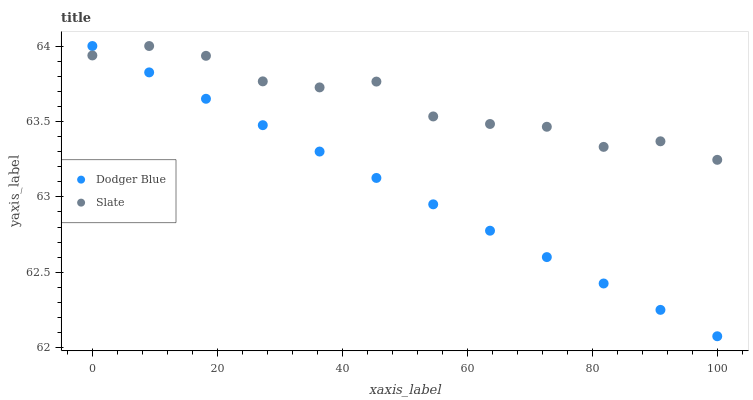Does Dodger Blue have the minimum area under the curve?
Answer yes or no. Yes. Does Slate have the maximum area under the curve?
Answer yes or no. Yes. Does Dodger Blue have the maximum area under the curve?
Answer yes or no. No. Is Dodger Blue the smoothest?
Answer yes or no. Yes. Is Slate the roughest?
Answer yes or no. Yes. Is Dodger Blue the roughest?
Answer yes or no. No. Does Dodger Blue have the lowest value?
Answer yes or no. Yes. Does Dodger Blue have the highest value?
Answer yes or no. Yes. Does Slate intersect Dodger Blue?
Answer yes or no. Yes. Is Slate less than Dodger Blue?
Answer yes or no. No. Is Slate greater than Dodger Blue?
Answer yes or no. No. 